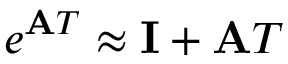<formula> <loc_0><loc_0><loc_500><loc_500>e ^ { A T } \approx I + A T</formula> 